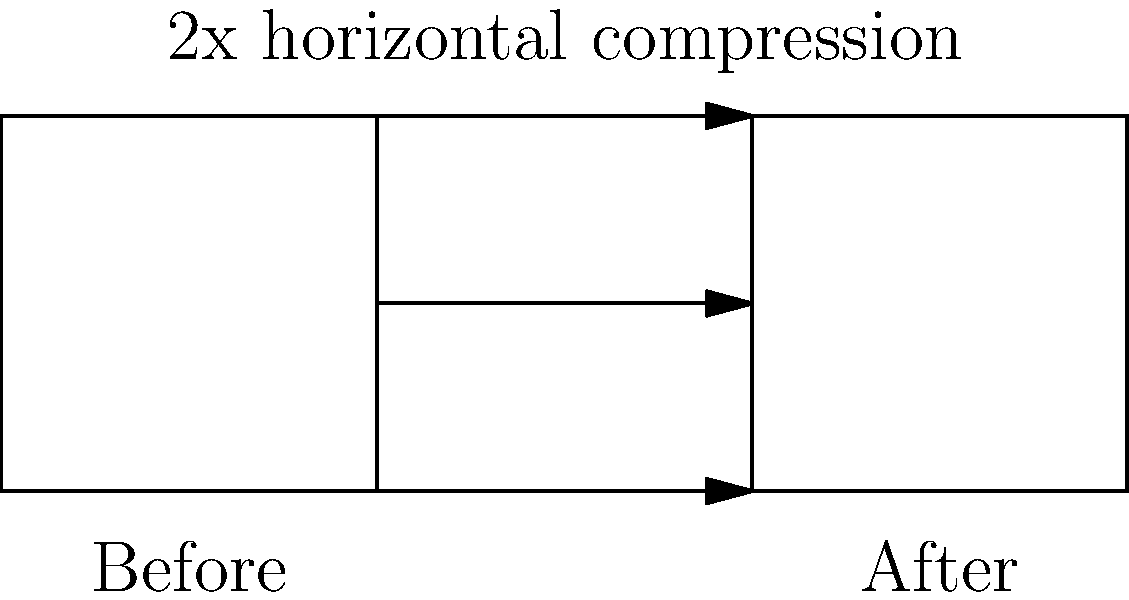In the context of anamorphic lenses used in cinematography, how does the horizontal compression ratio affect the field of view compared to spherical lenses? Consider the before and after images shown above. To understand the effect of anamorphic lenses on field of view, let's break it down step-by-step:

1. Anamorphic lenses compress the image horizontally during filming. In the diagram, we see a 2x horizontal compression.

2. The vertical dimension remains unchanged, while the horizontal dimension is squeezed.

3. This compression allows for a wider horizontal field of view to be captured on the film or sensor.

4. During projection or post-production, the image is stretched back out horizontally to its original aspect ratio.

5. The result is a wider aspect ratio than what would be achieved with a spherical lens on the same film or sensor size.

6. For example, if we start with a 4:3 sensor and use a 2x anamorphic lens:
   - The captured image is compressed to 2:3
   - When unsqueezed in post-production, it becomes 8:3 (or 2.66:1)

7. This wider aspect ratio is achieved without losing vertical resolution, which would occur if the image were simply cropped to a widescreen format.

8. The field of view is effectively increased horizontally by the compression factor of the lens. In this case, a 2x anamorphic lens doubles the horizontal field of view compared to a spherical lens of the same focal length.

Therefore, anamorphic lenses allow cinematographers to capture a wider field of view horizontally while maintaining the full vertical resolution of the sensor or film.
Answer: Doubles the horizontal field of view without changing vertical field of view 